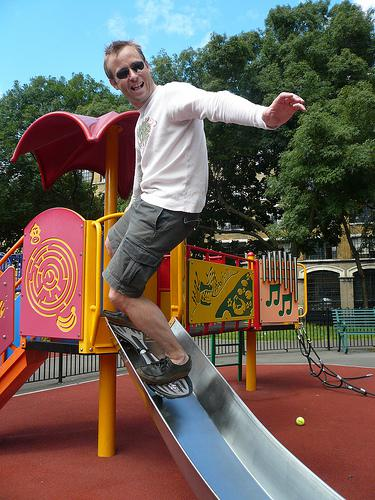Question: where are the glasses?
Choices:
A. On his head.
B. In his pocket.
C. In a case.
D. On the man's face.
Answer with the letter. Answer: D Question: what is this man doing?
Choices:
A. Walking.
B. Running.
C. Jogging.
D. Skateboarding.
Answer with the letter. Answer: D Question: how many children are visible?
Choices:
A. Two.
B. Ten.
C. Zero.
D. Four.
Answer with the letter. Answer: C 